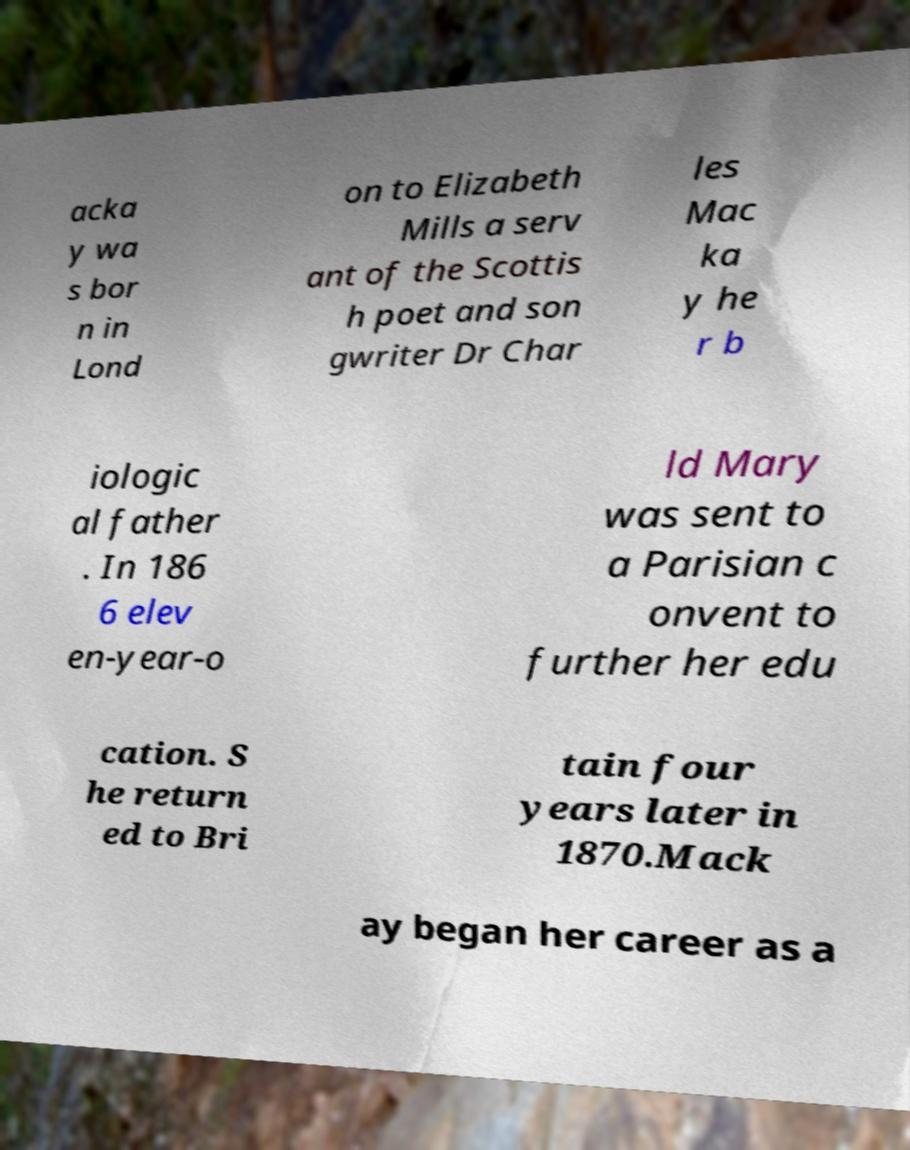What messages or text are displayed in this image? I need them in a readable, typed format. acka y wa s bor n in Lond on to Elizabeth Mills a serv ant of the Scottis h poet and son gwriter Dr Char les Mac ka y he r b iologic al father . In 186 6 elev en-year-o ld Mary was sent to a Parisian c onvent to further her edu cation. S he return ed to Bri tain four years later in 1870.Mack ay began her career as a 